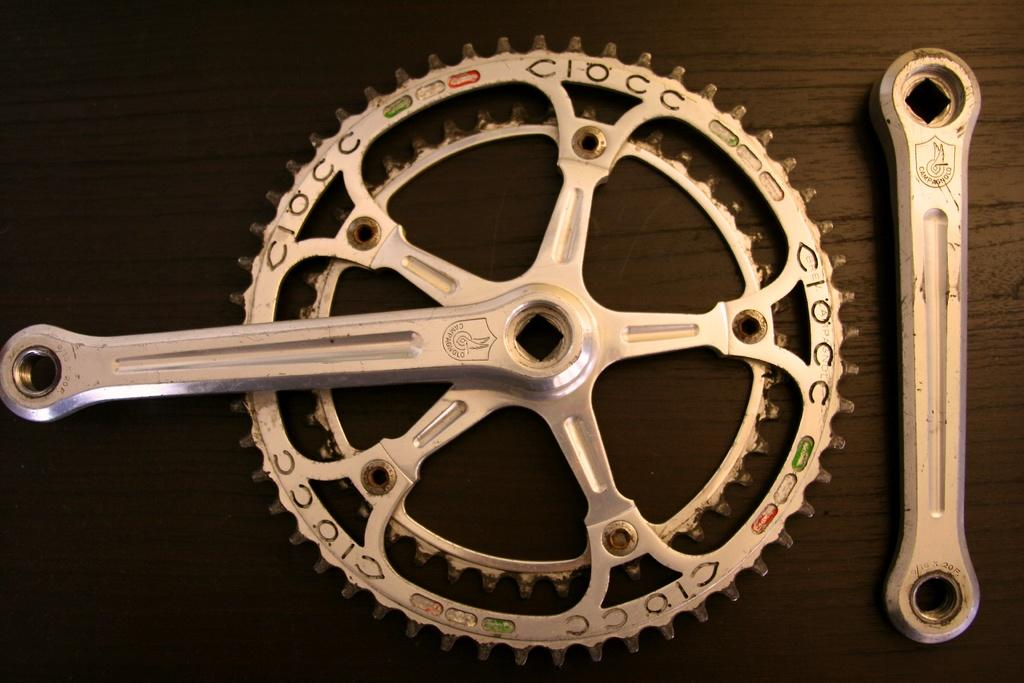What is the main subject of the image? The main subject of the image is a bicycle crankset. Can you describe the bicycle crankset in more detail? Unfortunately, the provided facts do not offer any additional details about the bicycle crankset. What type of attraction is near the bicycle crankset in the image? There is no information about any attractions near the bicycle crankset in the image. 